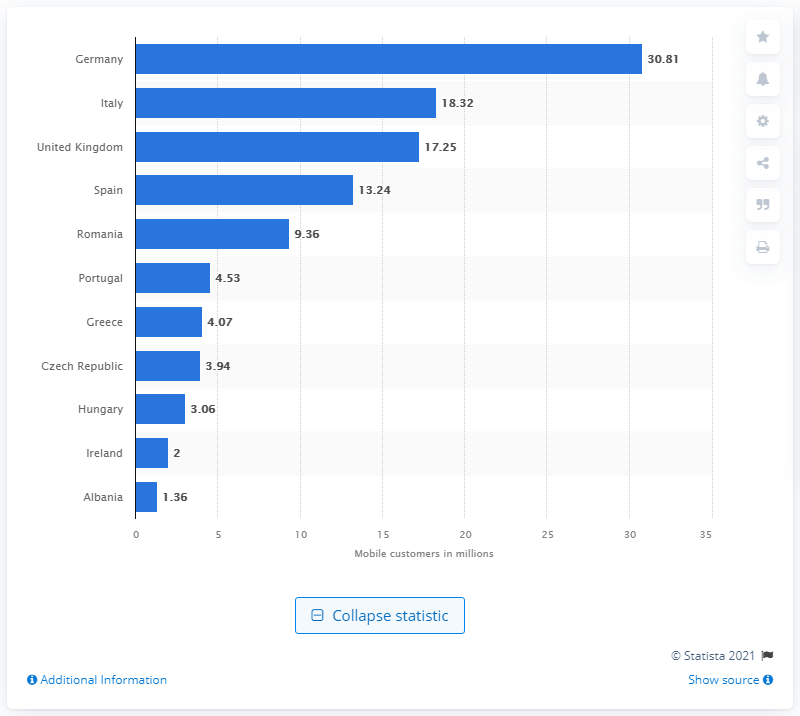Outline some significant characteristics in this image. At the end of the 2020/21 financial year, the total number of mobile customers in Germany was 30.81 million. 